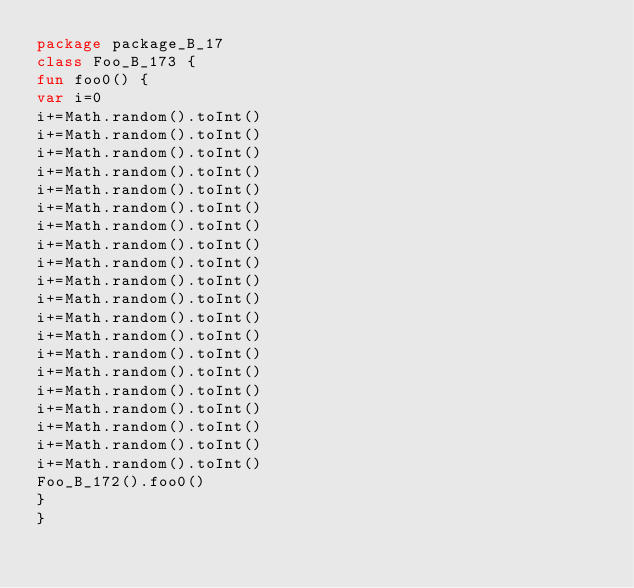Convert code to text. <code><loc_0><loc_0><loc_500><loc_500><_Kotlin_>package package_B_17
class Foo_B_173 {
fun foo0() {
var i=0
i+=Math.random().toInt()
i+=Math.random().toInt()
i+=Math.random().toInt()
i+=Math.random().toInt()
i+=Math.random().toInt()
i+=Math.random().toInt()
i+=Math.random().toInt()
i+=Math.random().toInt()
i+=Math.random().toInt()
i+=Math.random().toInt()
i+=Math.random().toInt()
i+=Math.random().toInt()
i+=Math.random().toInt()
i+=Math.random().toInt()
i+=Math.random().toInt()
i+=Math.random().toInt()
i+=Math.random().toInt()
i+=Math.random().toInt()
i+=Math.random().toInt()
i+=Math.random().toInt()
Foo_B_172().foo0()
}
}</code> 